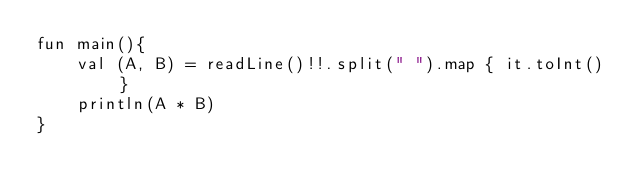<code> <loc_0><loc_0><loc_500><loc_500><_Kotlin_>fun main(){
    val (A, B) = readLine()!!.split(" ").map { it.toInt() }
    println(A * B)
}</code> 